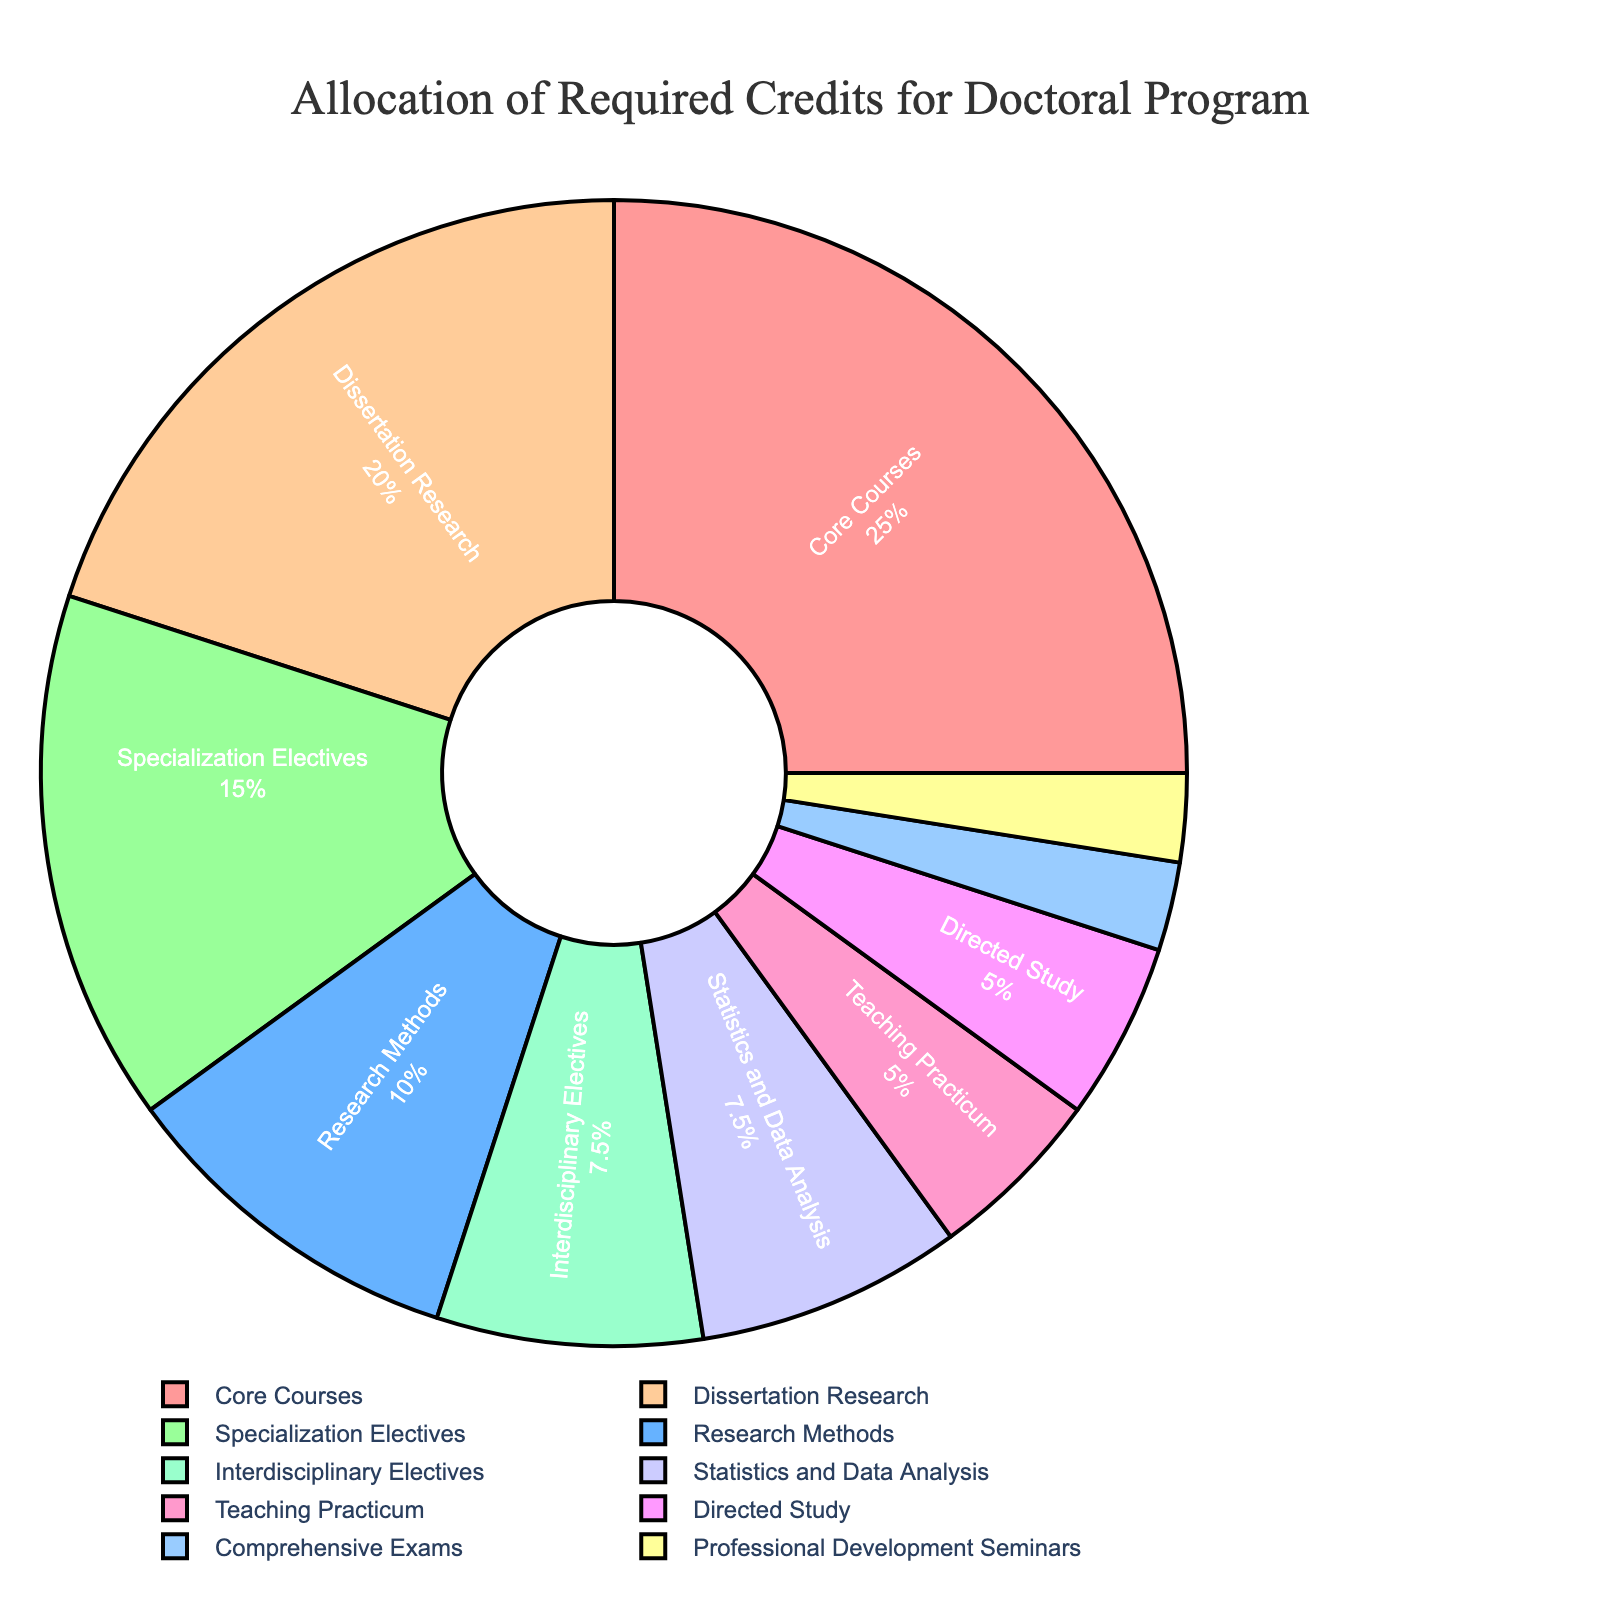Which category accounts for the largest share of credits? By looking at the pie chart, the segment with the largest percentage can be identified. The "Core Courses" category occupies the largest portion.
Answer: Core Courses What percentage of total credits is allocated to Dissertation Research? Locate the "Dissertation Research" segment and observe its percentage contribution on the pie chart.
Answer: 20% How do the credits for Specialization Electives compare to Interdisciplinary Electives? Compare the sizes of the "Specialization Electives" and "Interdisciplinary Electives" segments. Specialization Electives are larger.
Answer: Specialization Electives are larger What is the combined percentage of credits for Core Courses and Dissertation Research? Add the percentages of the "Core Courses" and "Dissertation Research" segments (50% + 20%).
Answer: 50% How many more credits are allocated to Professional Development Seminars than to Comprehensive Exams? Subtract the number of credits for "Comprehensive Exams" from the number of credits for "Professional Development Seminars" (3 - 3).
Answer: 0 Which category has the smallest allocation of credits? Identify the smallest segment in the pie chart which represents the category with the least credits. "Comprehensive Exams" has the smallest contribution.
Answer: Comprehensive Exams Are the credits for Research Methods more or less than those for Specialization Electives? Compare the sizes of the "Research Methods" and "Specialization Electives" segments. Research Methods has fewer credits.
Answer: Research Methods has fewer credits What is the total percentage allocation for categories with single-digit credits? Sum the percentages of segments with credits < 10 (Teaching Practicum, Comprehensive Exams, Professional Development Seminars, Directed Study, Interdisciplinary Electives, Statistics and Data Analysis) (5% + 2.5% + 2.5% + 5% + 7.5% + 7.5%).
Answer: 30% How many categories are there with more than 10 credits allocated? Count the segments with more than 10 credits in the pie chart (Core Courses, Research Methods, Specialization Electives, Dissertation Research).
Answer: Four categories What is the difference in credits between Core Courses and all categories with less than 10 credits combined? Subtract the total credits of all <10 categories from the "Core Courses" credits (30 - (6 + 3 + 3 + 6 + 9 + 9)).
Answer: -6 